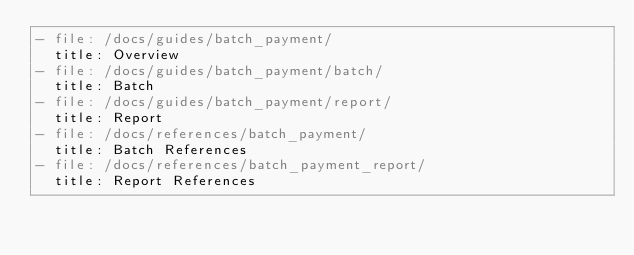<code> <loc_0><loc_0><loc_500><loc_500><_YAML_>- file: /docs/guides/batch_payment/
  title: Overview
- file: /docs/guides/batch_payment/batch/
  title: Batch
- file: /docs/guides/batch_payment/report/
  title: Report
- file: /docs/references/batch_payment/
  title: Batch References
- file: /docs/references/batch_payment_report/
  title: Report References
</code> 